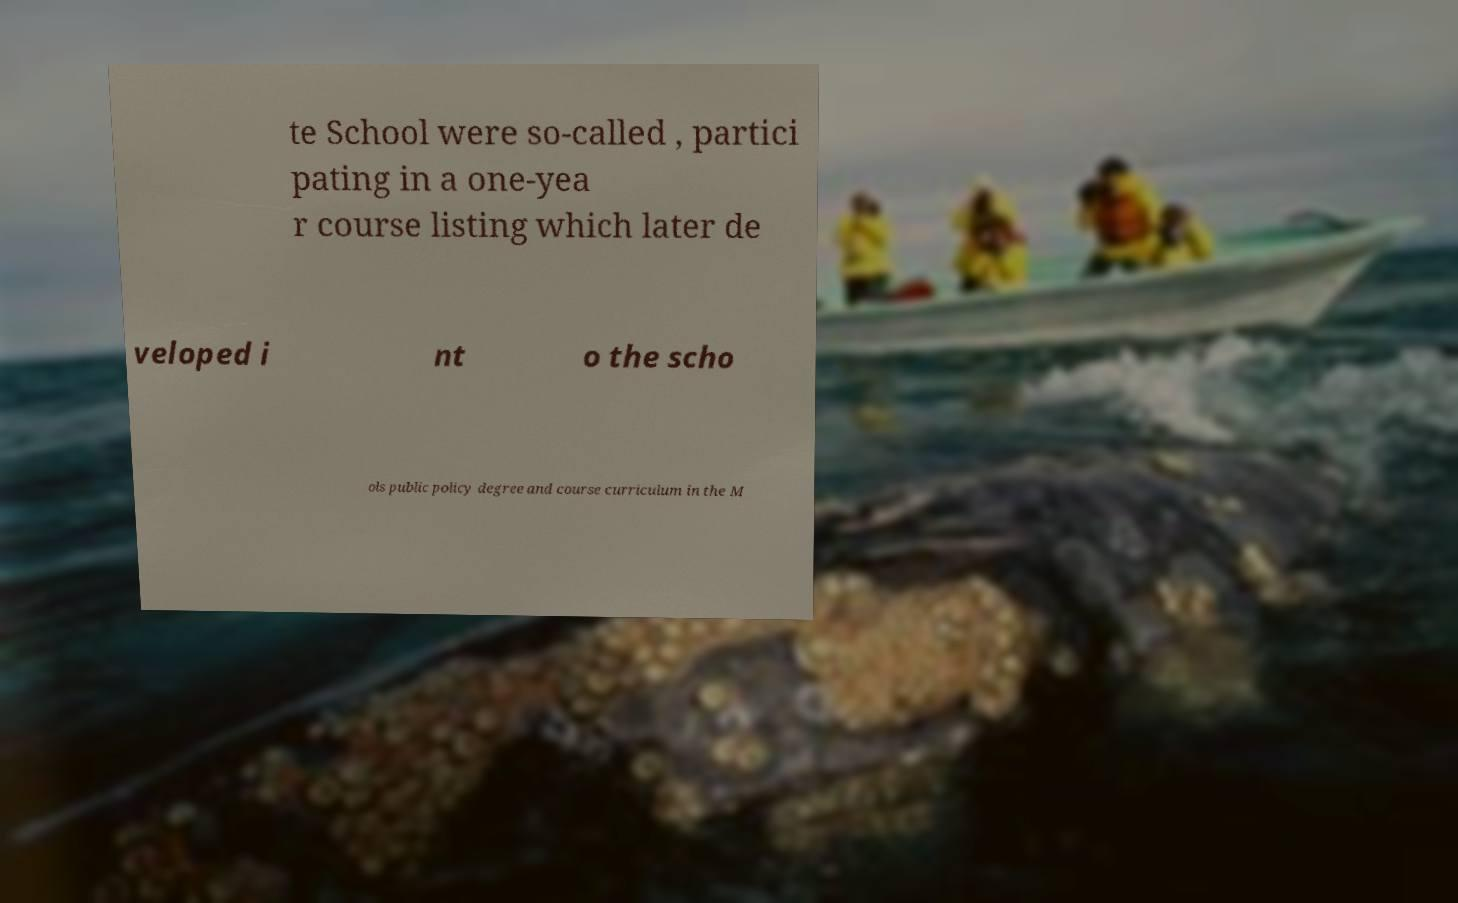Can you accurately transcribe the text from the provided image for me? te School were so-called , partici pating in a one-yea r course listing which later de veloped i nt o the scho ols public policy degree and course curriculum in the M 